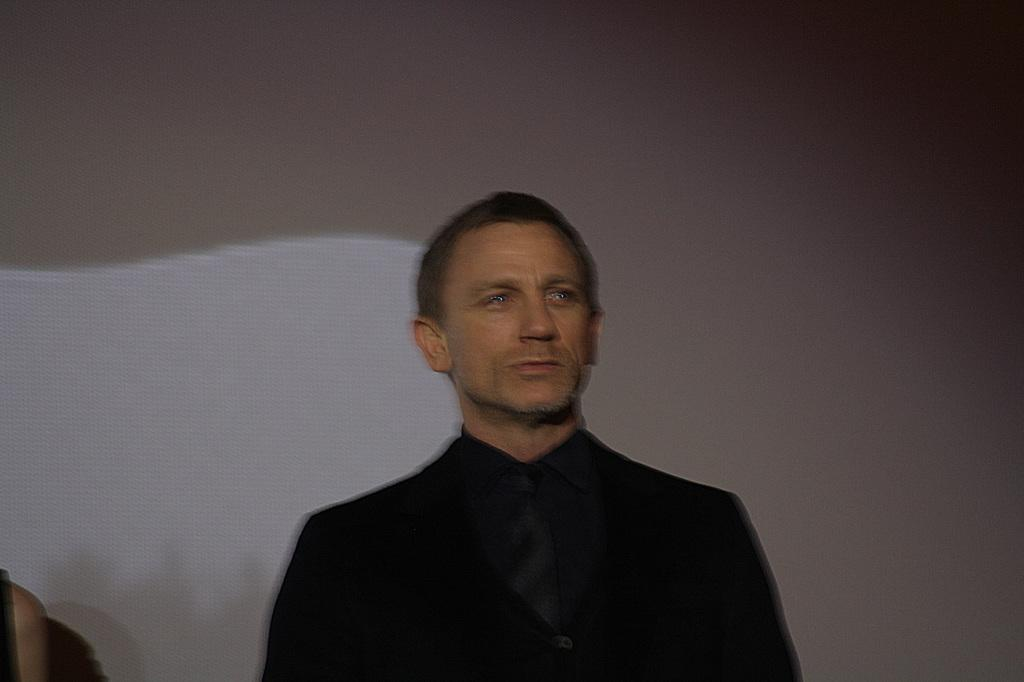What is the main subject of the image? There is a man standing in the image. What can be seen in the background of the image? There is a wall in the background of the image. Can you describe any other elements in the background? There is a person's hand visible in the background of the image. How many cubs are playing with the person's hand in the image? There are no cubs present in the image; only a man standing and a person's hand visible in the background. 